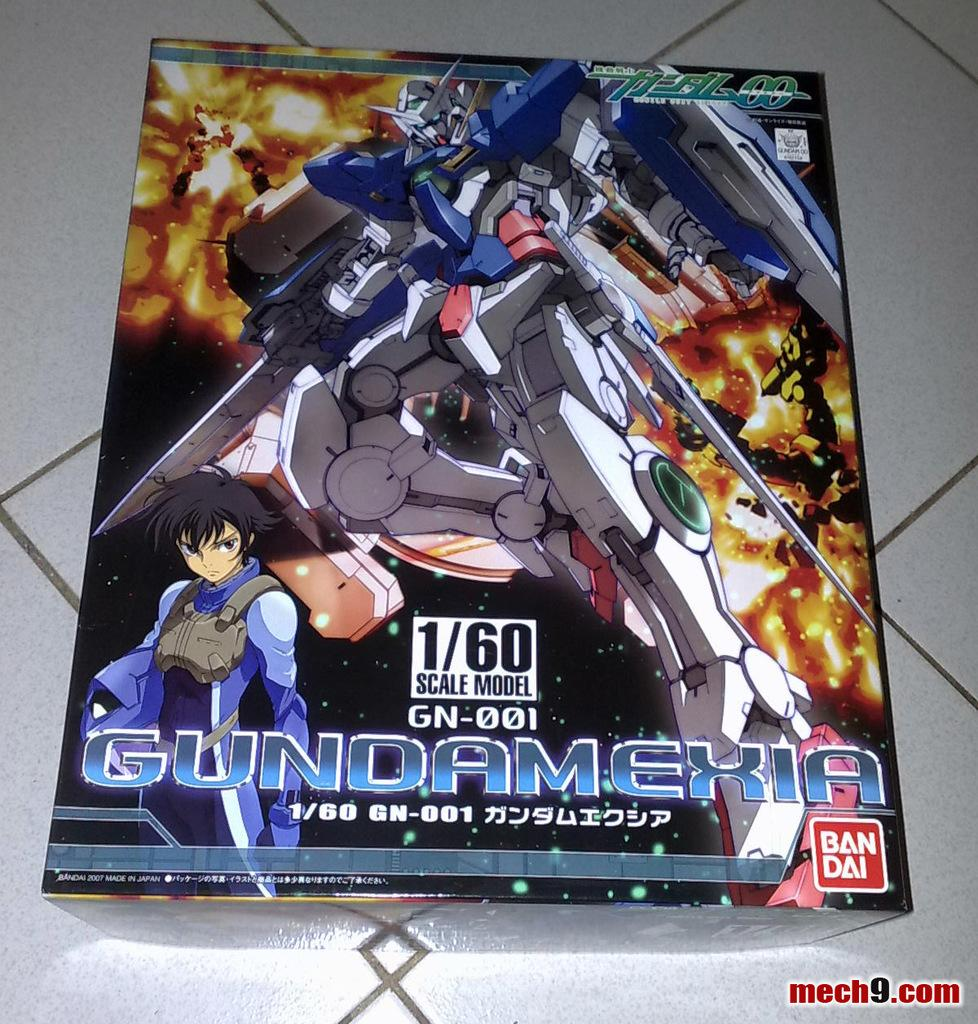<image>
Create a compact narrative representing the image presented. A box for a 1/60 model of Gundamexi sits on a tiled floor. 